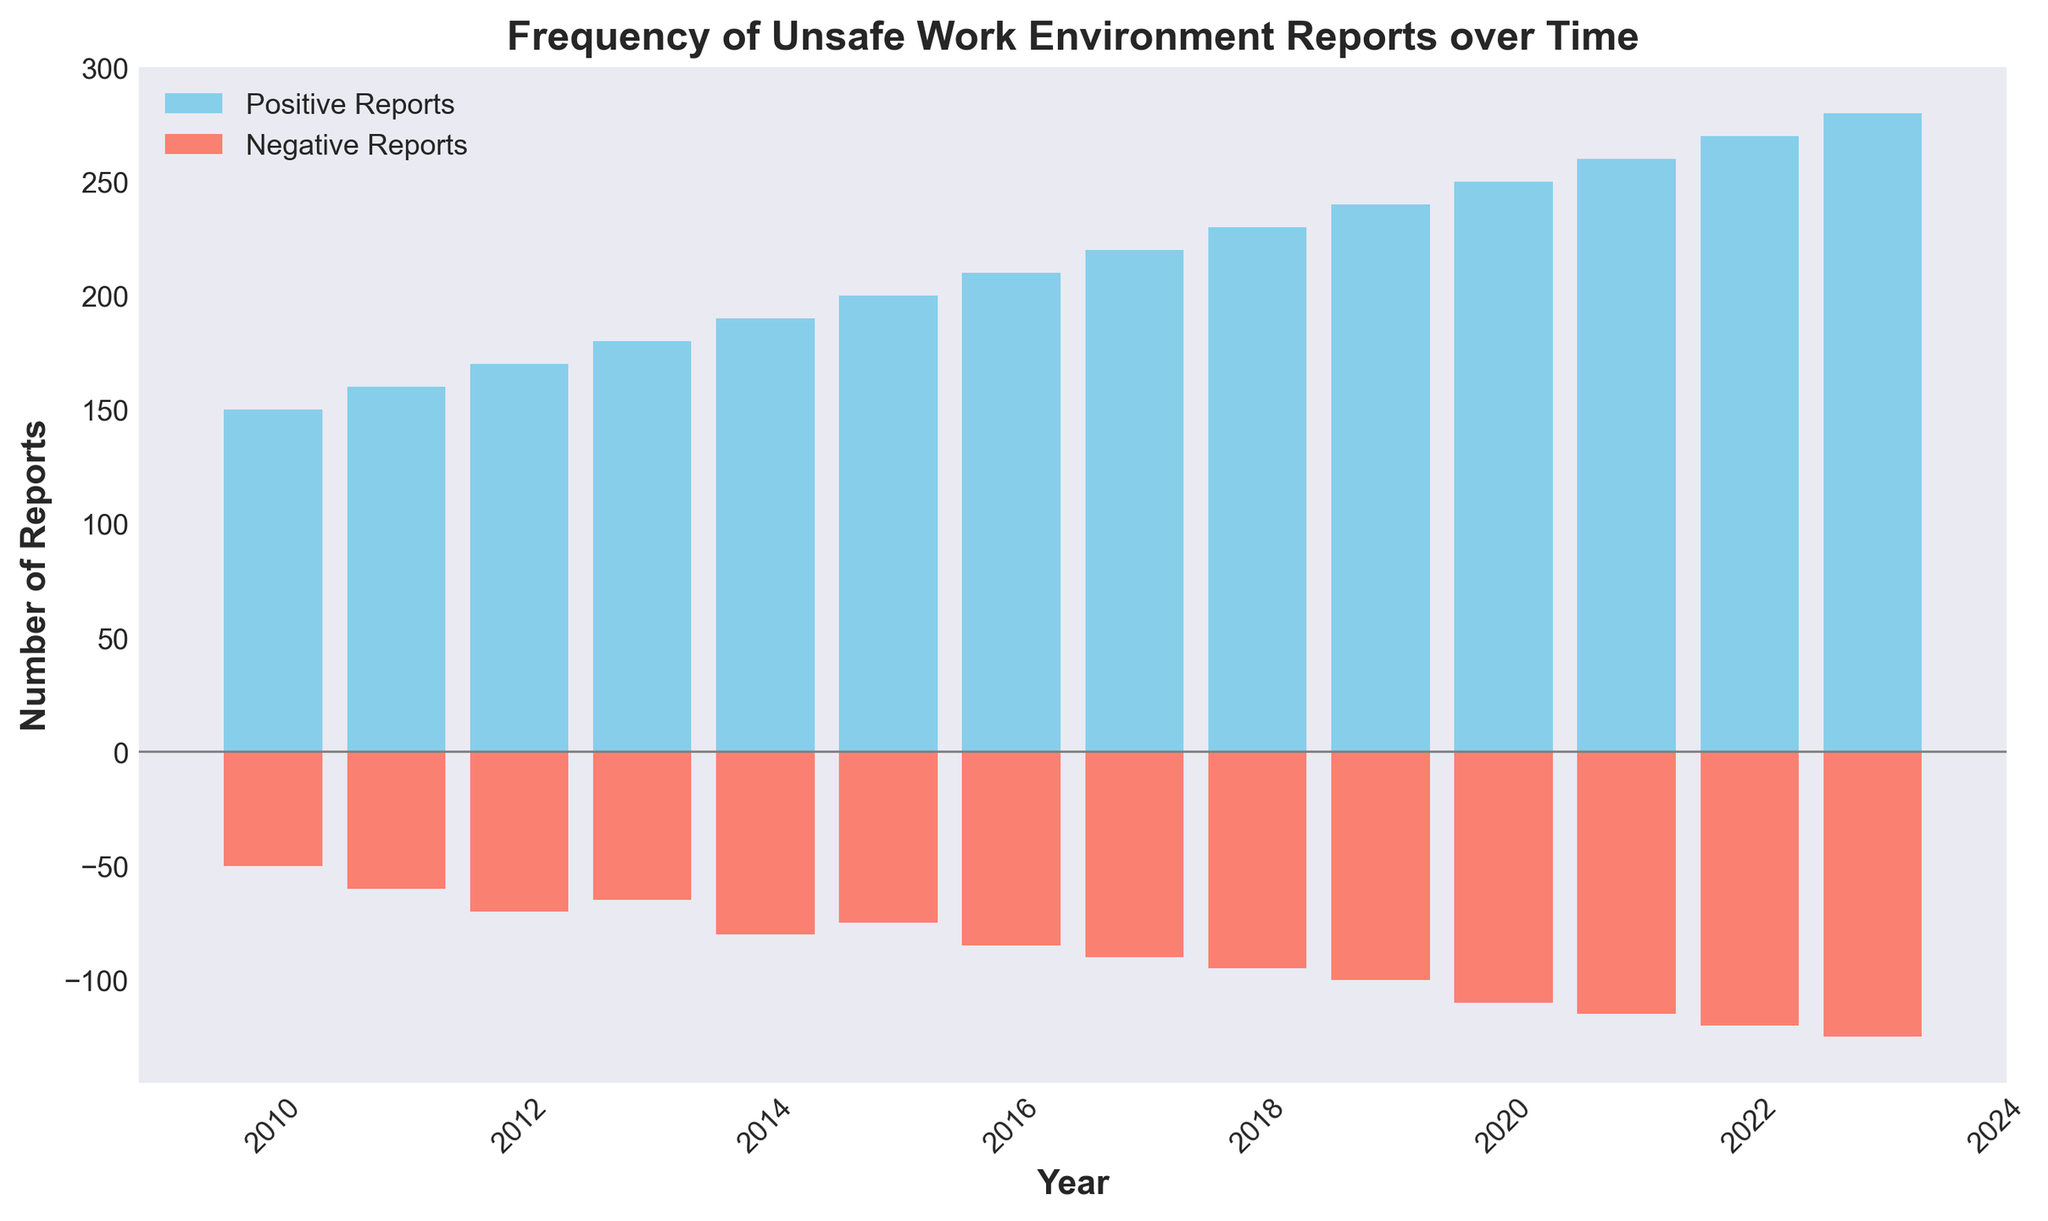What's the highest number of positive reports in a year? To find the highest number of positive reports, look at the highest bar in the positive reports (sky blue) section. The tallest bar is in 2023, which has 280 positive reports.
Answer: 280 What's the difference between positive and negative reports in 2020? For 2020, the positive reports are 250, and the negative reports are 110. The difference is 250 - 110.
Answer: 140 Which year had the least negative reports? To find the year with the least negative reports, identify the shortest bar in the negative reports (salmon) section. The shortest bar is in 2010, which has 50 negative reports.
Answer: 2010 What is the average number of negative reports between 2015 and 2020? The negative reports from 2015 to 2020 are: 75, 85, 90, 95, 100, and 110. The sum is 555, and the average is 555/6.
Answer: 92.5 In which year did the number of positive reports exceed 200 for the first time? Scan the sky blue bars to see when the positive reports first reach over 200. In 2015, the bar first goes beyond 200 with 200 positive reports.
Answer: 2015 How many more positive reports were there in 2023 compared to 2010? Calculate the difference between positive reports in 2023 and 2010. In 2023, there are 280 positive reports, and in 2010, there are 150. The difference is 280 - 150.
Answer: 130 What color represents negative reports, and how visually is it denoted? Negative reports are represented by the salmon-colored bars, shown as bars extending downwards (negative direction).
Answer: Salmon and downward bars What's the trend in positive reports from 2010 to 2023? Observing the sky blue bars from left to right, they generally increase in height each year, indicating an upward trend in positive reports from 2010 to 2023.
Answer: Increasing In which year was the gap between positive and negative reports the smallest? Examine the difference between the heights of sky blue and salmon bars for each year. In 2013, the difference is smallest with 180 positive and 65 negative reports.
Answer: 2013 